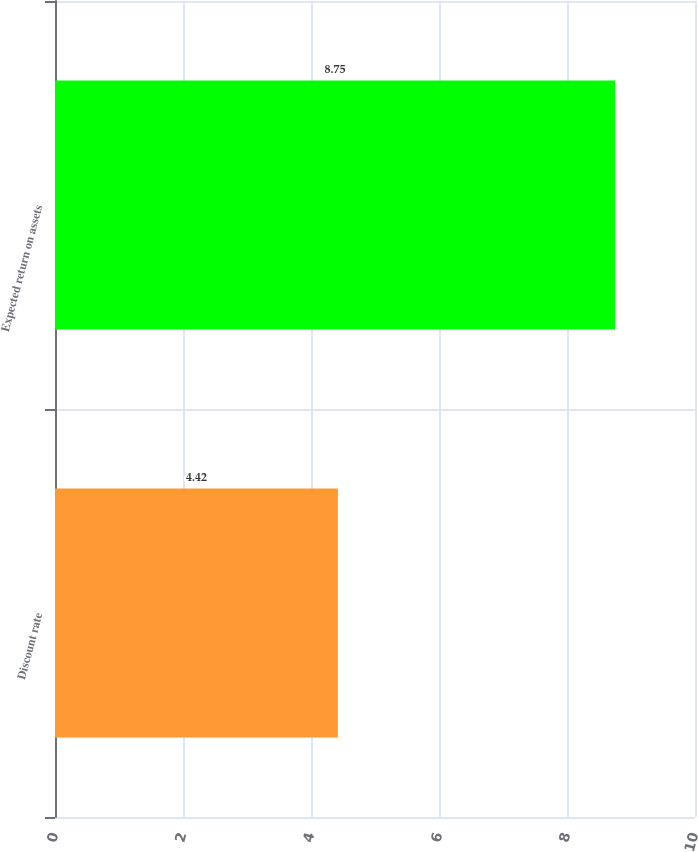Convert chart to OTSL. <chart><loc_0><loc_0><loc_500><loc_500><bar_chart><fcel>Discount rate<fcel>Expected return on assets<nl><fcel>4.42<fcel>8.75<nl></chart> 